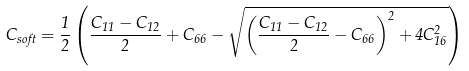Convert formula to latex. <formula><loc_0><loc_0><loc_500><loc_500>C _ { s o f t } = \frac { 1 } { 2 } \left ( \frac { C _ { 1 1 } - C _ { 1 2 } } { 2 } + C _ { 6 6 } - \sqrt { \left ( \frac { C _ { 1 1 } - C _ { 1 2 } } { 2 } - C _ { 6 6 } \right ) ^ { 2 } + 4 C _ { 1 6 } ^ { 2 } } \right )</formula> 